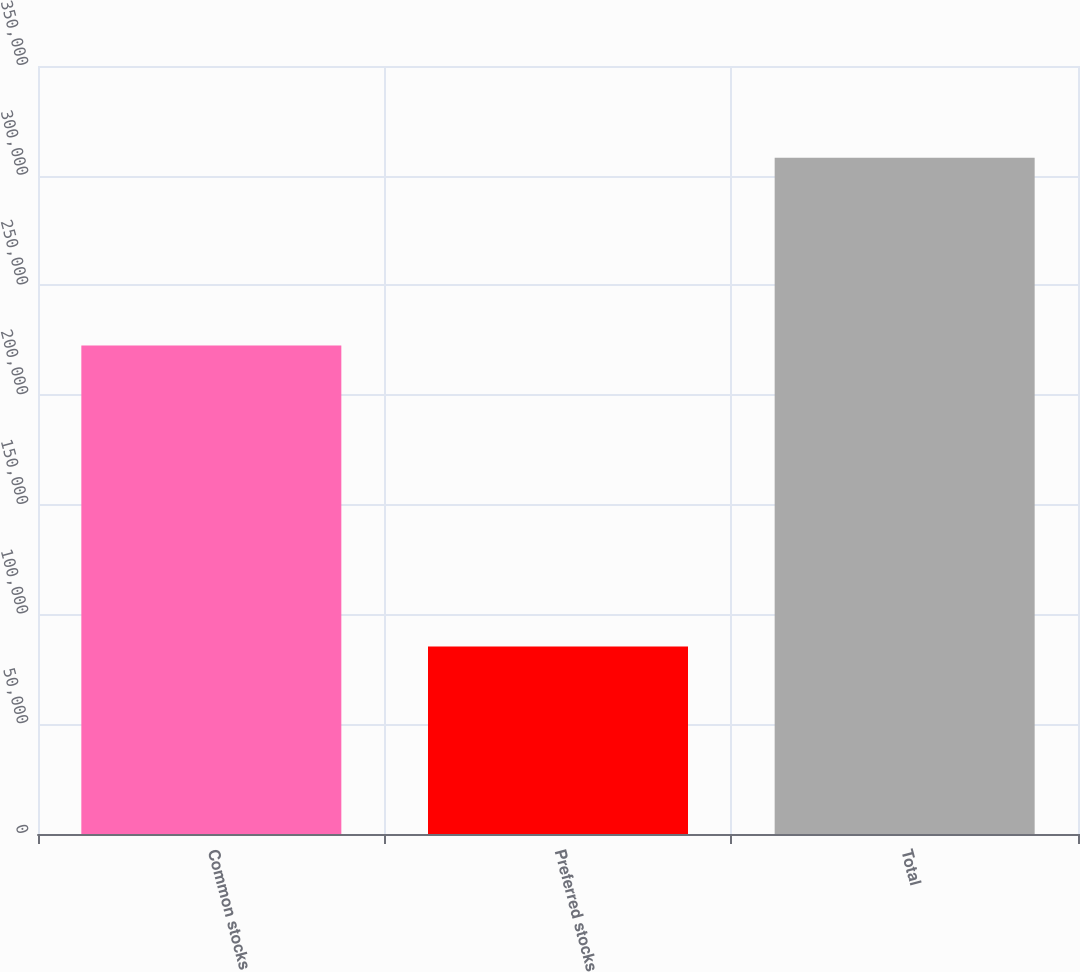Convert chart. <chart><loc_0><loc_0><loc_500><loc_500><bar_chart><fcel>Common stocks<fcel>Preferred stocks<fcel>Total<nl><fcel>222671<fcel>85504<fcel>308175<nl></chart> 